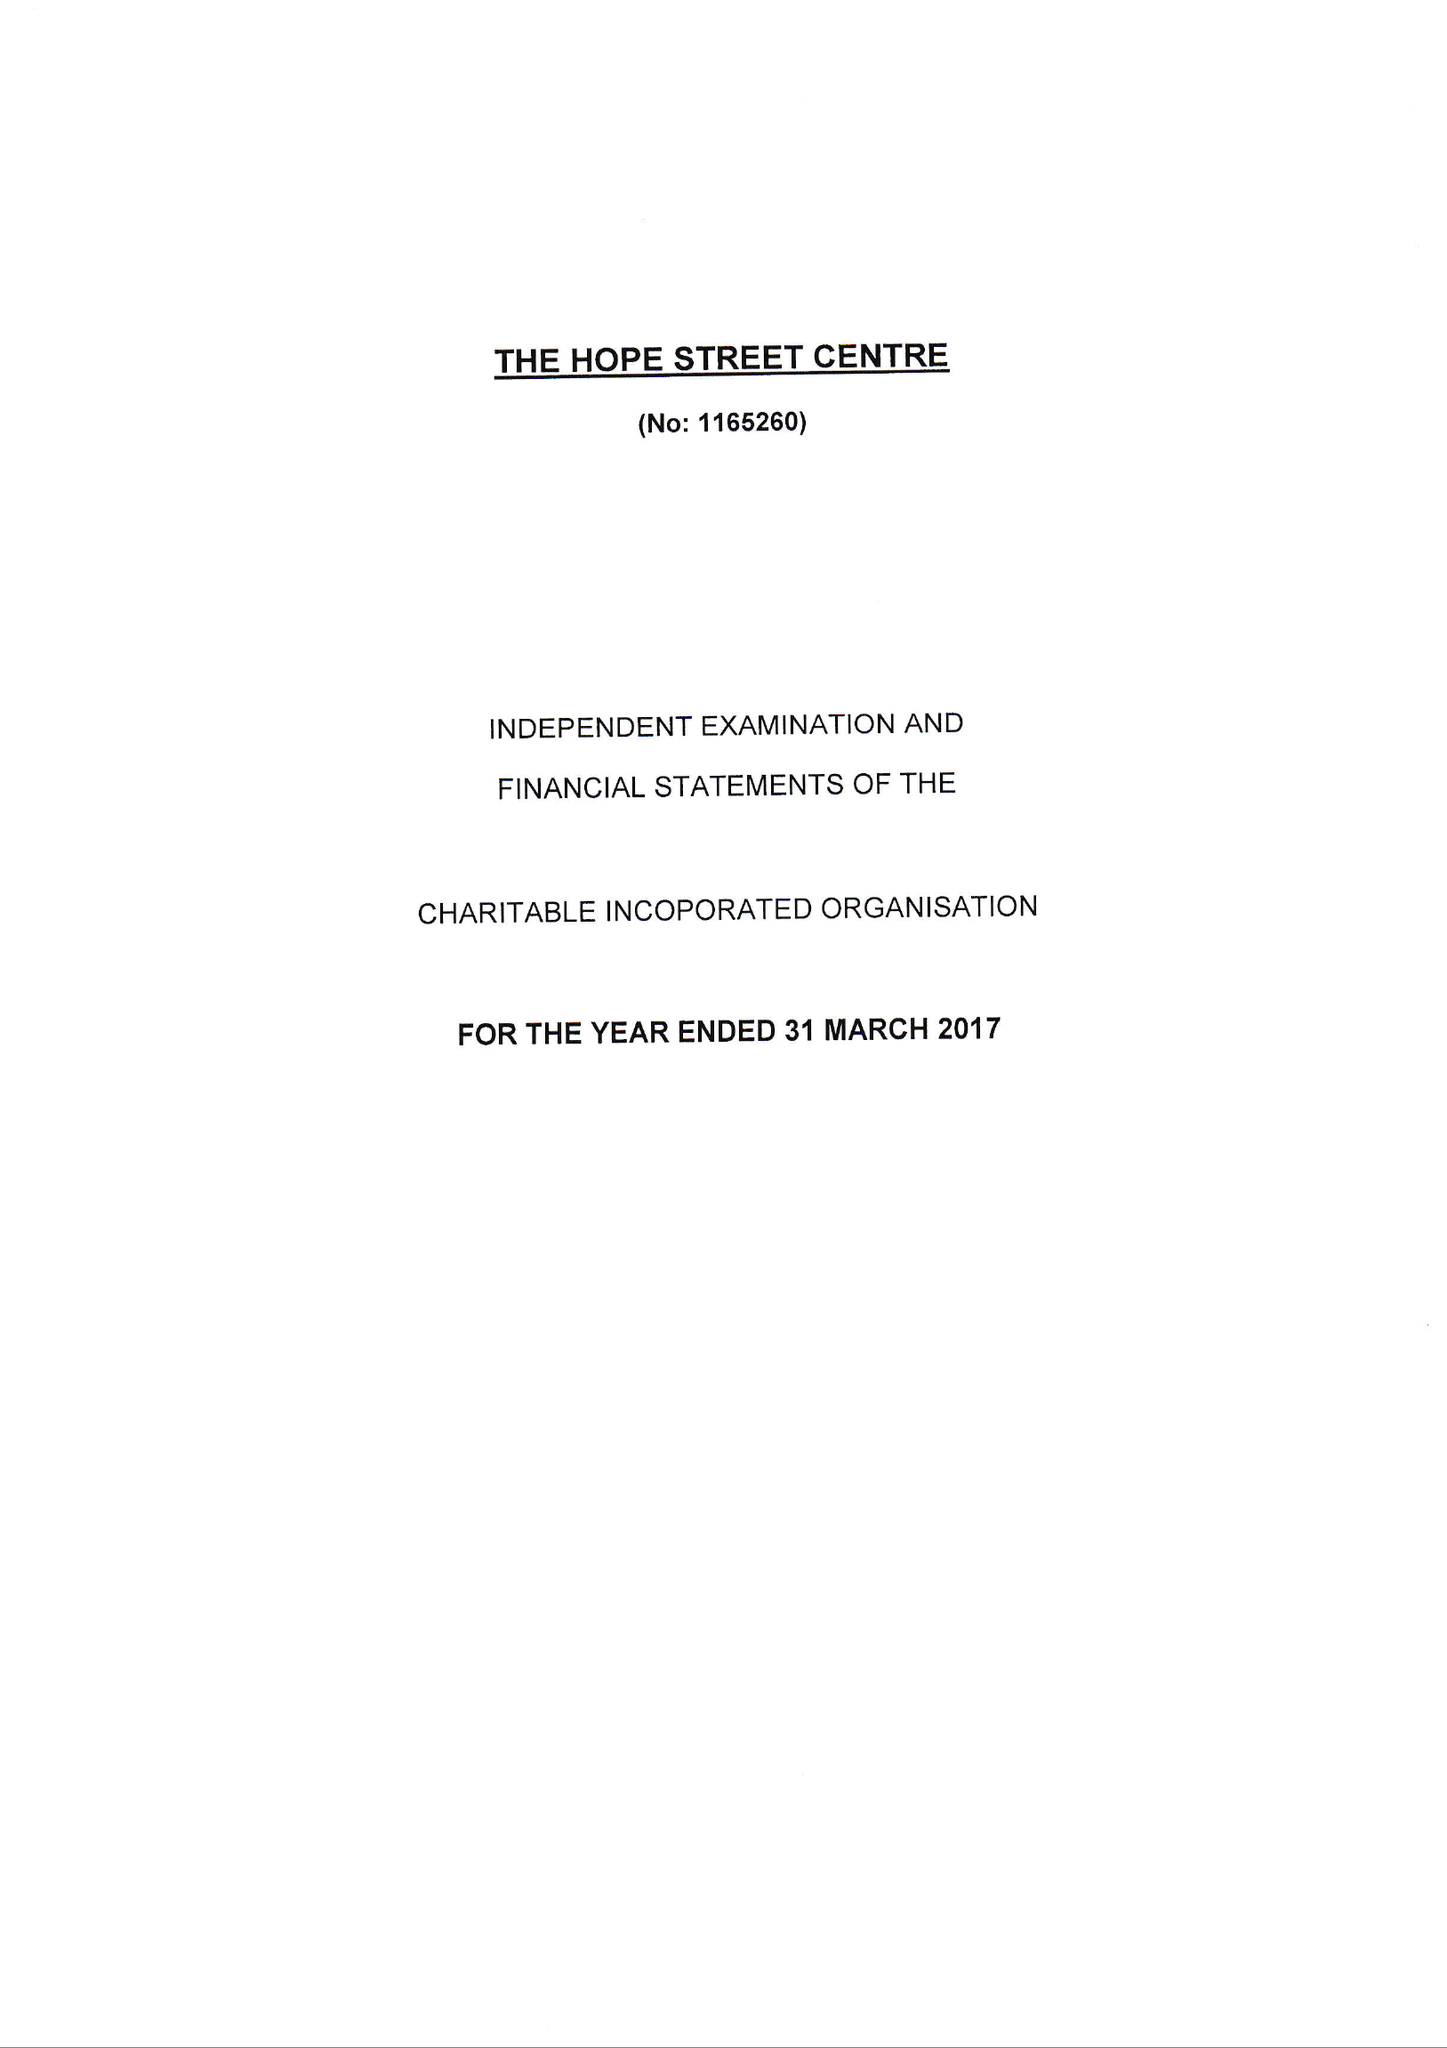What is the value for the income_annually_in_british_pounds?
Answer the question using a single word or phrase. 72961.00 